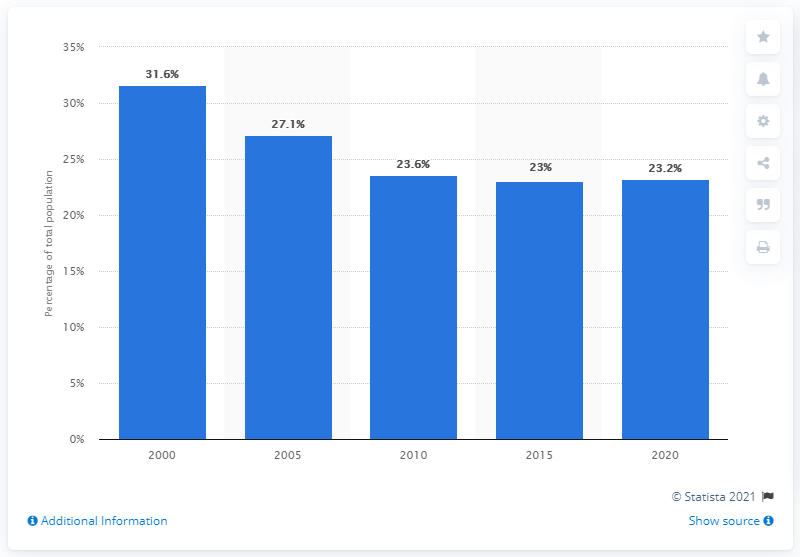Give some essential details in this illustration. In 2020, it was estimated that approximately 23.2% of the population in Vietnam were children. 